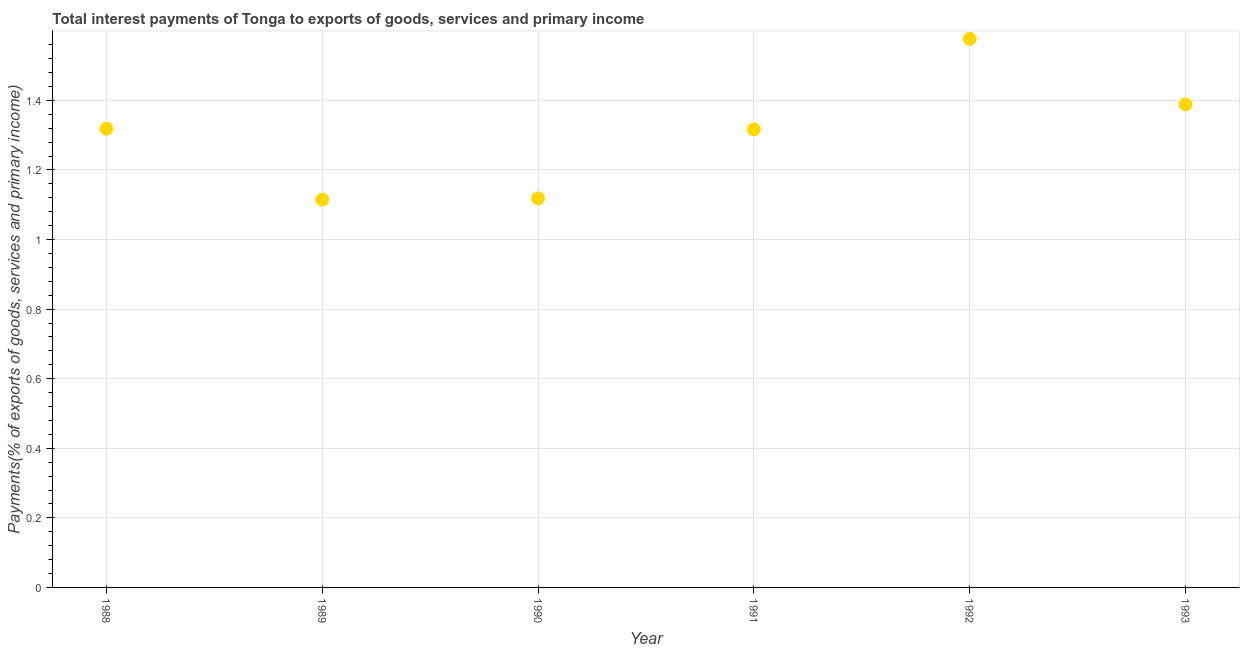What is the total interest payments on external debt in 1992?
Your answer should be compact. 1.58. Across all years, what is the maximum total interest payments on external debt?
Keep it short and to the point. 1.58. Across all years, what is the minimum total interest payments on external debt?
Ensure brevity in your answer.  1.11. In which year was the total interest payments on external debt minimum?
Offer a very short reply. 1989. What is the sum of the total interest payments on external debt?
Your answer should be very brief. 7.83. What is the difference between the total interest payments on external debt in 1989 and 1991?
Provide a short and direct response. -0.2. What is the average total interest payments on external debt per year?
Provide a short and direct response. 1.31. What is the median total interest payments on external debt?
Ensure brevity in your answer.  1.32. What is the ratio of the total interest payments on external debt in 1992 to that in 1993?
Give a very brief answer. 1.14. Is the total interest payments on external debt in 1989 less than that in 1992?
Ensure brevity in your answer.  Yes. What is the difference between the highest and the second highest total interest payments on external debt?
Offer a terse response. 0.19. What is the difference between the highest and the lowest total interest payments on external debt?
Provide a succinct answer. 0.46. Does the total interest payments on external debt monotonically increase over the years?
Offer a very short reply. No. How many dotlines are there?
Offer a terse response. 1. Are the values on the major ticks of Y-axis written in scientific E-notation?
Ensure brevity in your answer.  No. Does the graph contain grids?
Ensure brevity in your answer.  Yes. What is the title of the graph?
Provide a short and direct response. Total interest payments of Tonga to exports of goods, services and primary income. What is the label or title of the Y-axis?
Your answer should be very brief. Payments(% of exports of goods, services and primary income). What is the Payments(% of exports of goods, services and primary income) in 1988?
Ensure brevity in your answer.  1.32. What is the Payments(% of exports of goods, services and primary income) in 1989?
Your response must be concise. 1.11. What is the Payments(% of exports of goods, services and primary income) in 1990?
Keep it short and to the point. 1.12. What is the Payments(% of exports of goods, services and primary income) in 1991?
Make the answer very short. 1.32. What is the Payments(% of exports of goods, services and primary income) in 1992?
Ensure brevity in your answer.  1.58. What is the Payments(% of exports of goods, services and primary income) in 1993?
Offer a very short reply. 1.39. What is the difference between the Payments(% of exports of goods, services and primary income) in 1988 and 1989?
Your answer should be compact. 0.2. What is the difference between the Payments(% of exports of goods, services and primary income) in 1988 and 1990?
Ensure brevity in your answer.  0.2. What is the difference between the Payments(% of exports of goods, services and primary income) in 1988 and 1991?
Offer a very short reply. 0. What is the difference between the Payments(% of exports of goods, services and primary income) in 1988 and 1992?
Your response must be concise. -0.26. What is the difference between the Payments(% of exports of goods, services and primary income) in 1988 and 1993?
Provide a short and direct response. -0.07. What is the difference between the Payments(% of exports of goods, services and primary income) in 1989 and 1990?
Your answer should be compact. -0. What is the difference between the Payments(% of exports of goods, services and primary income) in 1989 and 1991?
Your response must be concise. -0.2. What is the difference between the Payments(% of exports of goods, services and primary income) in 1989 and 1992?
Your response must be concise. -0.46. What is the difference between the Payments(% of exports of goods, services and primary income) in 1989 and 1993?
Offer a terse response. -0.27. What is the difference between the Payments(% of exports of goods, services and primary income) in 1990 and 1991?
Your answer should be compact. -0.2. What is the difference between the Payments(% of exports of goods, services and primary income) in 1990 and 1992?
Your answer should be very brief. -0.46. What is the difference between the Payments(% of exports of goods, services and primary income) in 1990 and 1993?
Your answer should be very brief. -0.27. What is the difference between the Payments(% of exports of goods, services and primary income) in 1991 and 1992?
Give a very brief answer. -0.26. What is the difference between the Payments(% of exports of goods, services and primary income) in 1991 and 1993?
Ensure brevity in your answer.  -0.07. What is the difference between the Payments(% of exports of goods, services and primary income) in 1992 and 1993?
Provide a short and direct response. 0.19. What is the ratio of the Payments(% of exports of goods, services and primary income) in 1988 to that in 1989?
Provide a short and direct response. 1.18. What is the ratio of the Payments(% of exports of goods, services and primary income) in 1988 to that in 1990?
Offer a very short reply. 1.18. What is the ratio of the Payments(% of exports of goods, services and primary income) in 1988 to that in 1992?
Keep it short and to the point. 0.84. What is the ratio of the Payments(% of exports of goods, services and primary income) in 1989 to that in 1990?
Offer a very short reply. 1. What is the ratio of the Payments(% of exports of goods, services and primary income) in 1989 to that in 1991?
Keep it short and to the point. 0.85. What is the ratio of the Payments(% of exports of goods, services and primary income) in 1989 to that in 1992?
Provide a succinct answer. 0.71. What is the ratio of the Payments(% of exports of goods, services and primary income) in 1989 to that in 1993?
Make the answer very short. 0.8. What is the ratio of the Payments(% of exports of goods, services and primary income) in 1990 to that in 1991?
Your answer should be compact. 0.85. What is the ratio of the Payments(% of exports of goods, services and primary income) in 1990 to that in 1992?
Make the answer very short. 0.71. What is the ratio of the Payments(% of exports of goods, services and primary income) in 1990 to that in 1993?
Keep it short and to the point. 0.81. What is the ratio of the Payments(% of exports of goods, services and primary income) in 1991 to that in 1992?
Your answer should be very brief. 0.83. What is the ratio of the Payments(% of exports of goods, services and primary income) in 1991 to that in 1993?
Ensure brevity in your answer.  0.95. What is the ratio of the Payments(% of exports of goods, services and primary income) in 1992 to that in 1993?
Your answer should be very brief. 1.14. 